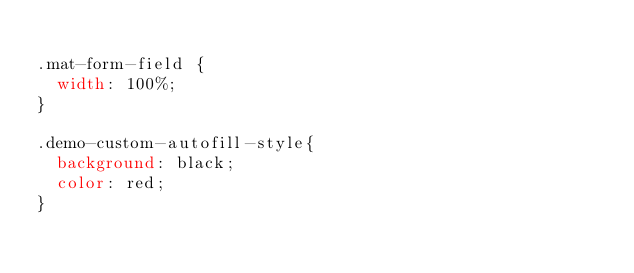<code> <loc_0><loc_0><loc_500><loc_500><_CSS_>
.mat-form-field {
  width: 100%;
}

.demo-custom-autofill-style{
  background: black;
  color: red;
}
</code> 